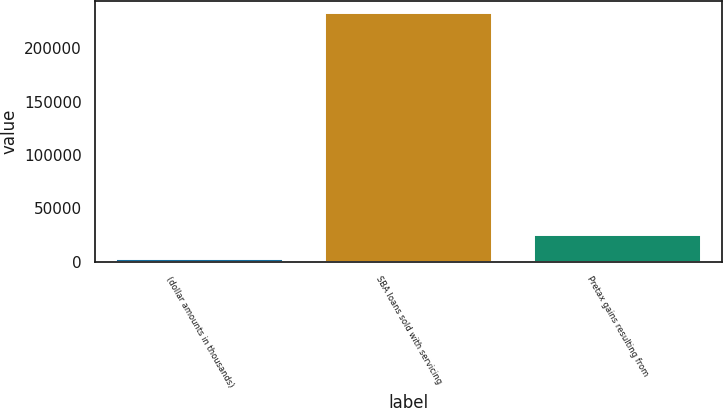Convert chart to OTSL. <chart><loc_0><loc_0><loc_500><loc_500><bar_chart><fcel>(dollar amounts in thousands)<fcel>SBA loans sold with servicing<fcel>Pretax gains resulting from<nl><fcel>2015<fcel>232848<fcel>25098.3<nl></chart> 